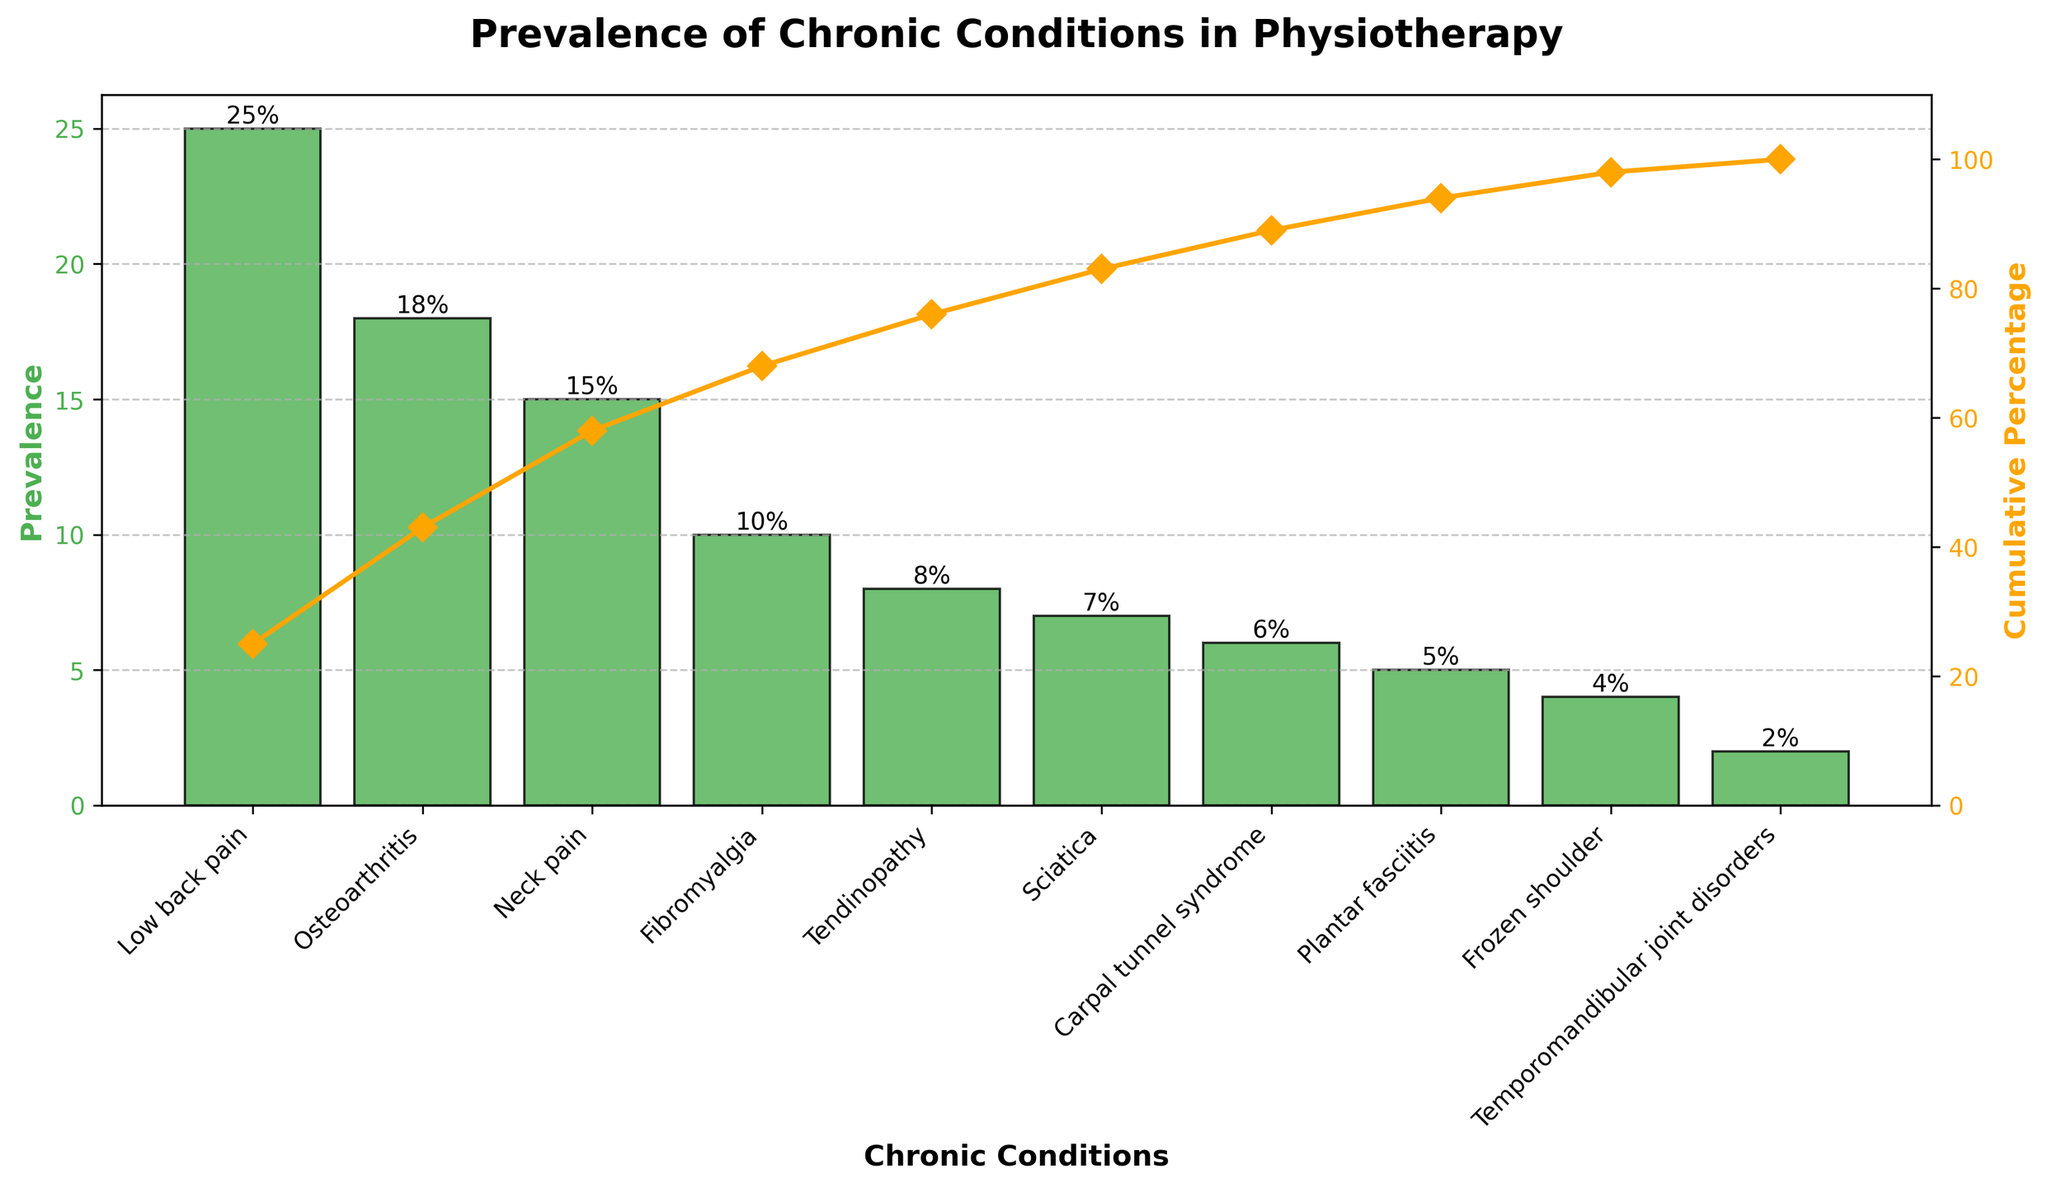How many chronic conditions are listed in the figure? Count the number of bars in the chart or the distinct labels on the x-axis. There are 10 chronic conditions listed.
Answer: 10 What chronic condition has the highest prevalence? Identify the tallest bar on the chart. The tallest bar represents Low back pain.
Answer: Low back pain What is the prevalence of osteoarthritis? Locate the bar corresponding to osteoarthritis and read the height labeled on top. The height is 18%.
Answer: 18% Which chronic condition has the lowest prevalence? Identify the shortest bar on the chart. The shortest bar represents Temporomandibular joint disorders.
Answer: Temporomandibular joint disorders What is the cumulative percentage after accounting for the top three chronic conditions? Look at the cumulative percentage line and its markers for the top three conditions (Low back pain, Osteoarthritis, Neck pain). The cumulative percentage is around 58%.
Answer: 58% What is the total prevalence percentage for low back pain and tendinopathy combined? Add the prevalence percentages for Low back pain (25%) and Tendinopathy (8%). 25% + 8% = 33%.
Answer: 33% How does the prevalence of sciatica compare to carpal tunnel syndrome? Compare the heights of the bars. Sciatica has a prevalence of 7% while Carpal tunnel syndrome has 6%. Sciatica is higher by 1%.
Answer: Sciatica is higher What is the prevalence difference between neck pain and fibromyalgia? Subtract the prevalence percentage of Fibromyalgia (10%) from Neck pain (15%). 15% - 10% = 5%.
Answer: 5% Which chronic conditions collectively make up exactly 50% of the prevalence? Add the prevalence percentages starting from the highest until the sum is closest to 50%. Low back pain (25%) + Osteoarthritis (18%) + Neck pain (15%) reaches more than 50%, but Low back pain + Osteoarthritis almost meets the cumulative 50%. These two conditions collectively amount to 43%.
Answer: Low back pain and Osteoarthritis What is the prevalence of chronic conditions that have a cumulative percentage below 85%? Add the prevalence percentages successively until the cumulative percentage reaches 85%. The conditions are Low back pain, Osteoarthritis, Neck pain, Fibromyalgia, Tendinopathy, and Sciatica. Their combined prevalence is 25% + 18% + 15% + 10% + 8% + 7% = 83%.
Answer: 83% 